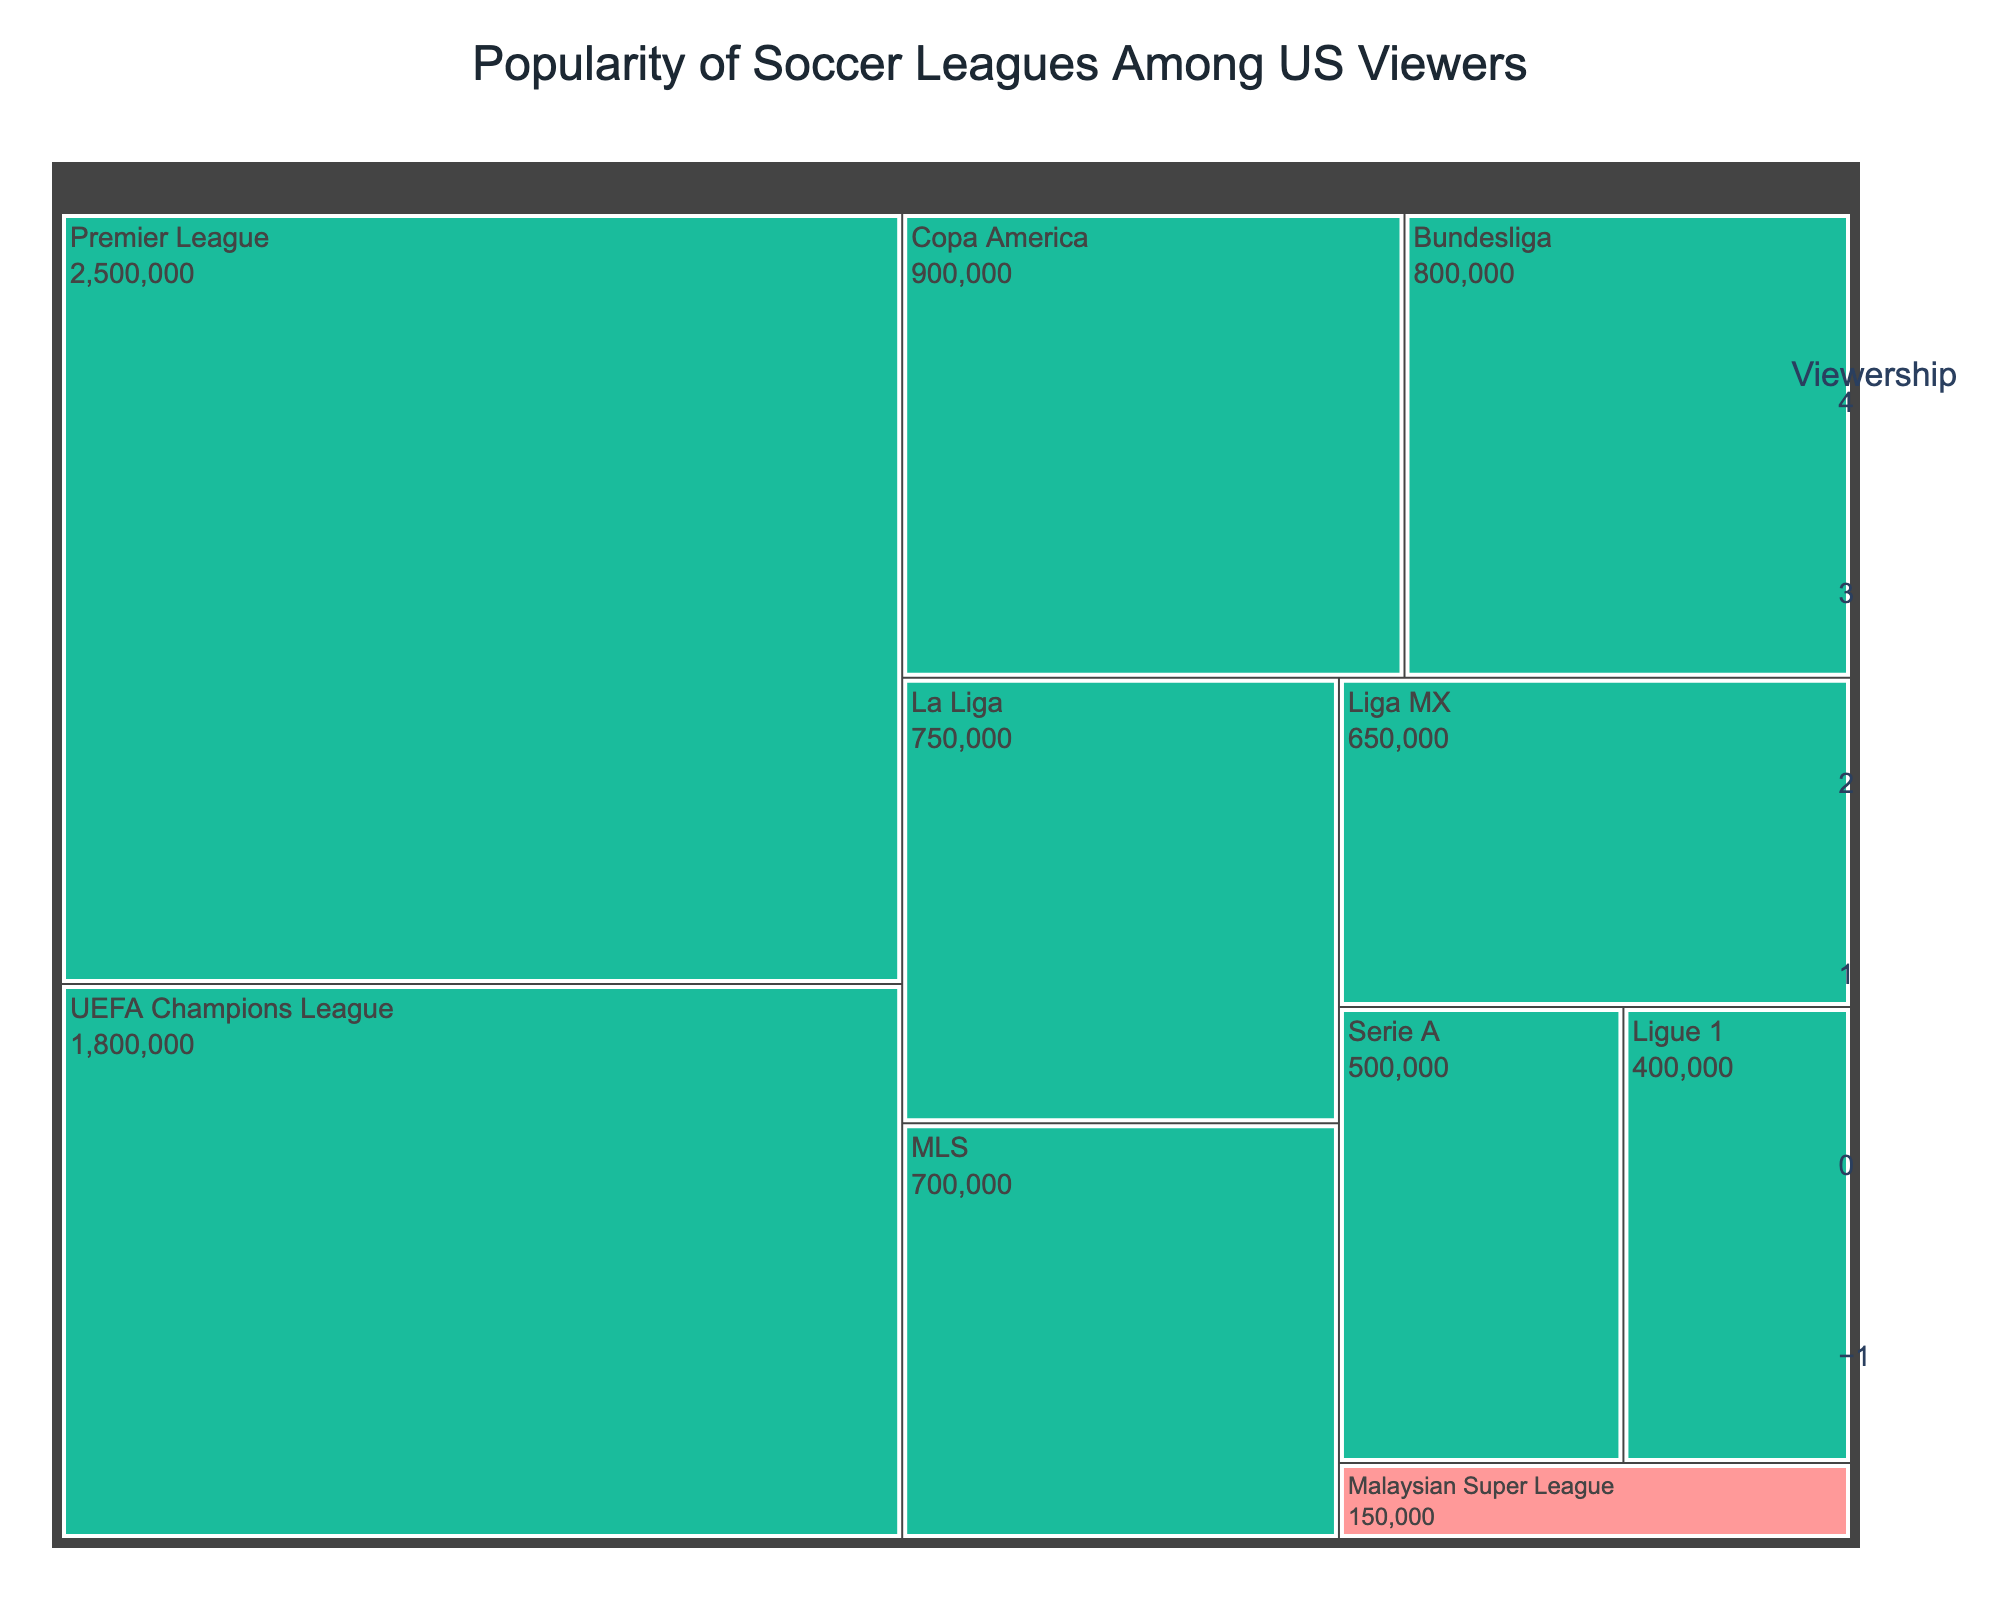what is the title of the figure? The title of the treemap is prominently displayed at the top center of the figure. In this case, it helps to provide context for the data being visualized.
Answer: Popularity of Soccer Leagues Among US Viewers Which league has the highest viewership according to the treemap? By scanning the treemap, the box for the Premier League is the largest, indicating it has the highest viewership.
Answer: Premier League What color is used to highlight Malaysian Super League in the treemap? In the figure, the Malaysian Super League is highlighted with a different color compared to others. It specifically uses a light pinkish-red color to stand out.
Answer: light pinkish-red How many leagues have viewerships greater than 1 million? By inspecting each segment in the treemap and noting their viewerships, we find: Premier League (2,500,000), UEFA Champions League (1,800,000), and Copa America (900,000). Only the first two have viewerships greater than 1 million.
Answer: 2 What is the combined viewership of MLS and Liga MX? Adding the viewerships of MLS (700,000) and Liga MX (650,000), we get 700,000 + 650,000 = 1,350,000.
Answer: 1,350,000 Which leagues have a lower viewership than the Malaysian Super League? By comparing the viewerships, Malaysian Super League has 150,000. All other leagues on the plot have higher viewerships, so there are no leagues with a lower viewership.
Answer: None How does the viewership of Ligue 1 compare with Serie A? By comparing the viewership values, Ligue 1 (400,000) and Serie A (500,000), we see that Ligue 1 has fewer viewers than Serie A.
Answer: Ligue 1 has fewer viewers than Serie A Which league has the third highest viewership? By examining the viewership values, the league with the third highest viewership falls after Premier League and UEFA Champions League. Copa America with 900,000 viewers holds this position.
Answer: Copa America What is the total viewership of all leagues combined? Summing up all the viewership numbers: 2,500,000 + 800,000 + 750,000 + 700,000 + 650,000 + 500,000 + 150,000 + 400,000 + 1,800,000 + 900,000 = 8,150,000.
Answer: 8,150,000 What are the two least popular leagues among US viewers? By looking at the smallest segments in the treemap, we see that Malaysian Super League (150,000) and Ligue 1 (400,000) have the least viewership.
Answer: Malaysian Super League and Ligue 1 